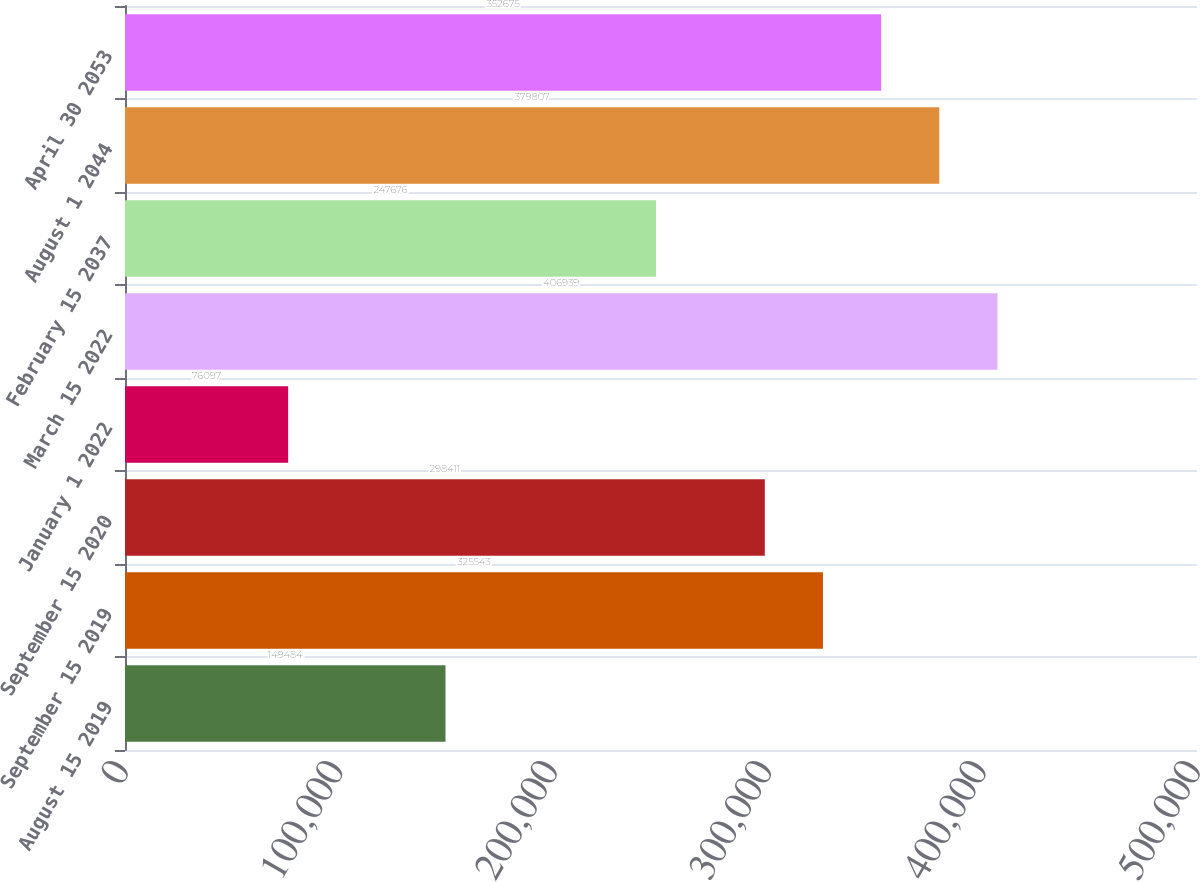Convert chart. <chart><loc_0><loc_0><loc_500><loc_500><bar_chart><fcel>August 15 2019<fcel>September 15 2019<fcel>September 15 2020<fcel>January 1 2022<fcel>March 15 2022<fcel>February 15 2037<fcel>August 1 2044<fcel>April 30 2053<nl><fcel>149484<fcel>325543<fcel>298411<fcel>76097<fcel>406939<fcel>247676<fcel>379807<fcel>352675<nl></chart> 